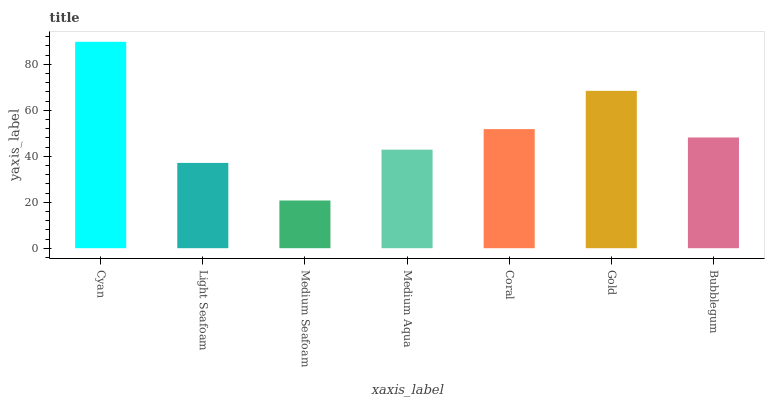Is Medium Seafoam the minimum?
Answer yes or no. Yes. Is Cyan the maximum?
Answer yes or no. Yes. Is Light Seafoam the minimum?
Answer yes or no. No. Is Light Seafoam the maximum?
Answer yes or no. No. Is Cyan greater than Light Seafoam?
Answer yes or no. Yes. Is Light Seafoam less than Cyan?
Answer yes or no. Yes. Is Light Seafoam greater than Cyan?
Answer yes or no. No. Is Cyan less than Light Seafoam?
Answer yes or no. No. Is Bubblegum the high median?
Answer yes or no. Yes. Is Bubblegum the low median?
Answer yes or no. Yes. Is Cyan the high median?
Answer yes or no. No. Is Medium Seafoam the low median?
Answer yes or no. No. 